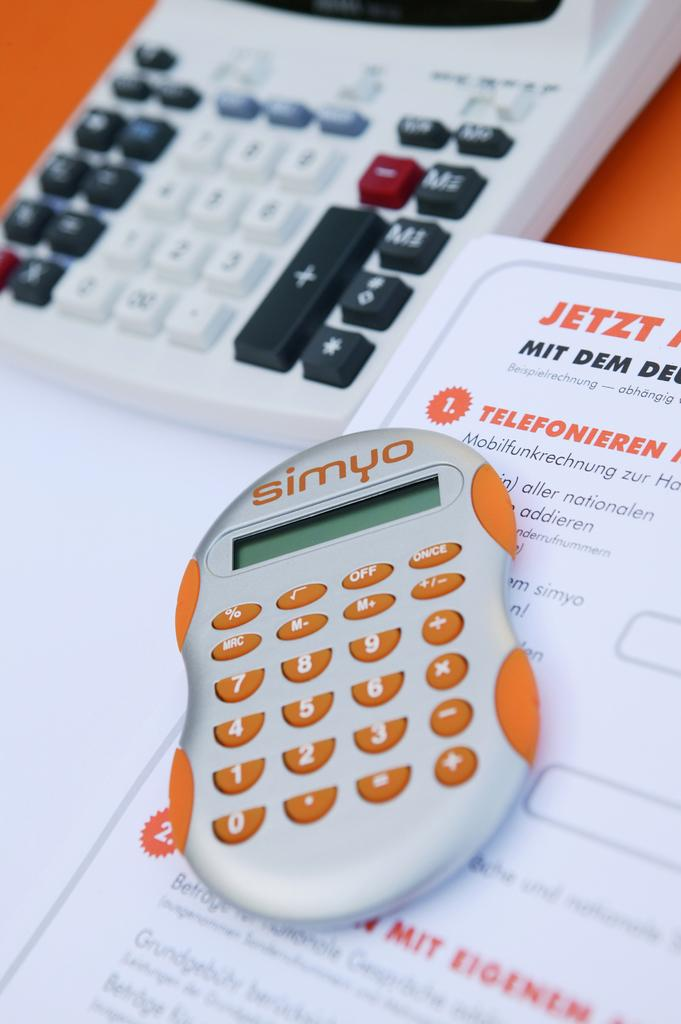<image>
Provide a brief description of the given image. an orange and silver calculator with the brand simyo at the top 